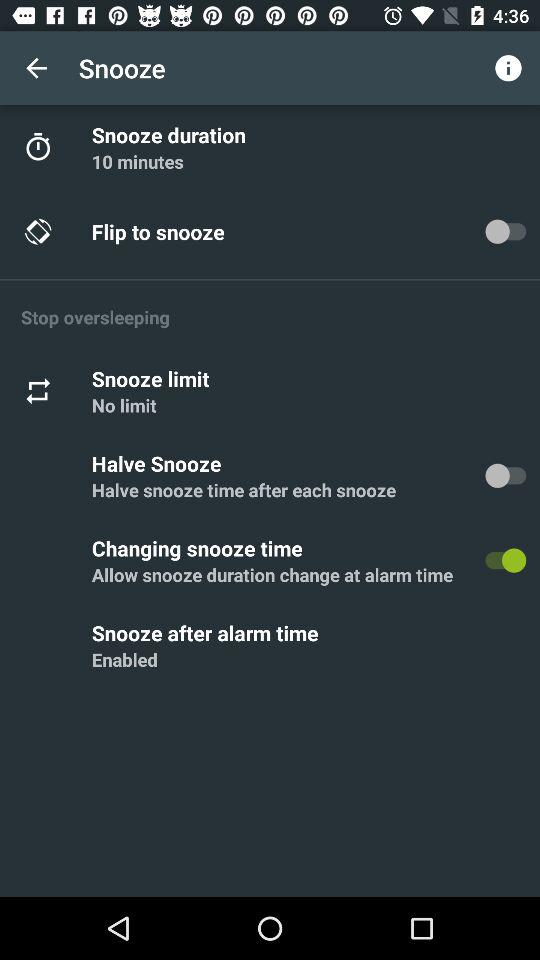What is the status of Halves snooze? The status is "off". 